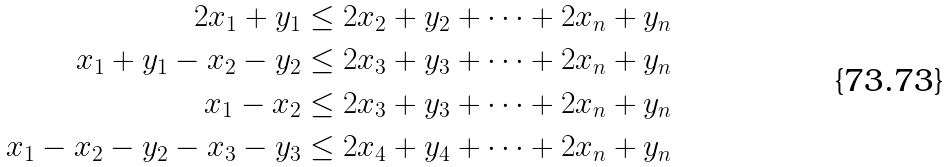Convert formula to latex. <formula><loc_0><loc_0><loc_500><loc_500>2 x _ { 1 } + y _ { 1 } \leq 2 x _ { 2 } + y _ { 2 } + \dots + 2 x _ { n } + y _ { n } \\ x _ { 1 } + y _ { 1 } - x _ { 2 } - y _ { 2 } \leq 2 x _ { 3 } + y _ { 3 } + \dots + 2 x _ { n } + y _ { n } \\ x _ { 1 } - x _ { 2 } \leq 2 x _ { 3 } + y _ { 3 } + \dots + 2 x _ { n } + y _ { n } \\ x _ { 1 } - x _ { 2 } - y _ { 2 } - x _ { 3 } - y _ { 3 } \leq 2 x _ { 4 } + y _ { 4 } + \dots + 2 x _ { n } + y _ { n }</formula> 